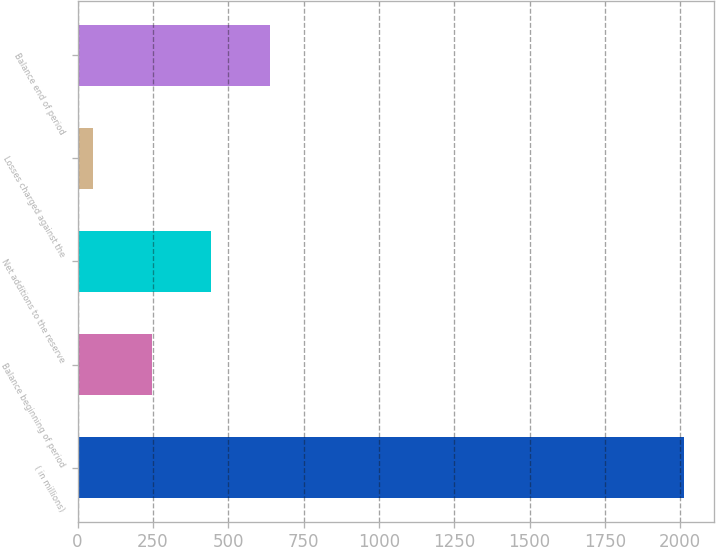<chart> <loc_0><loc_0><loc_500><loc_500><bar_chart><fcel>( in millions)<fcel>Balance beginning of period<fcel>Net additions to the reserve<fcel>Losses charged against the<fcel>Balance end of period<nl><fcel>2012<fcel>248<fcel>444<fcel>52<fcel>640<nl></chart> 